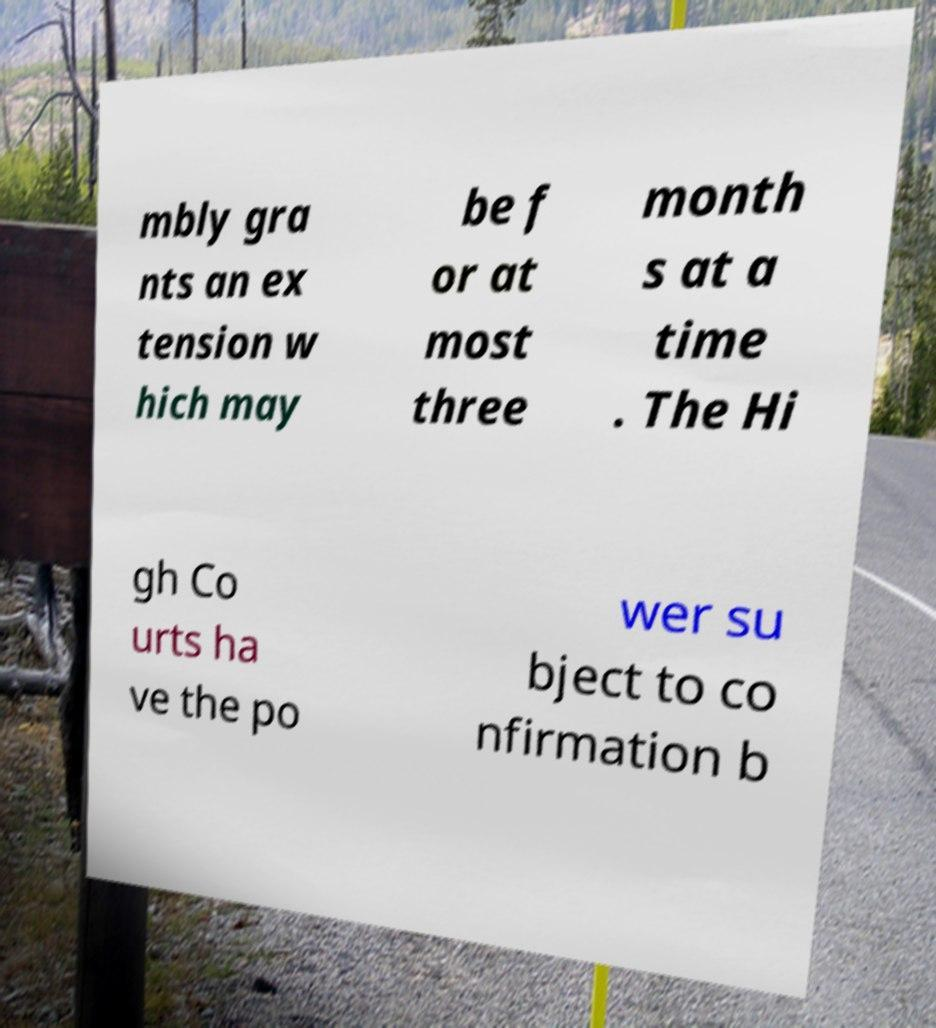Can you read and provide the text displayed in the image?This photo seems to have some interesting text. Can you extract and type it out for me? mbly gra nts an ex tension w hich may be f or at most three month s at a time . The Hi gh Co urts ha ve the po wer su bject to co nfirmation b 